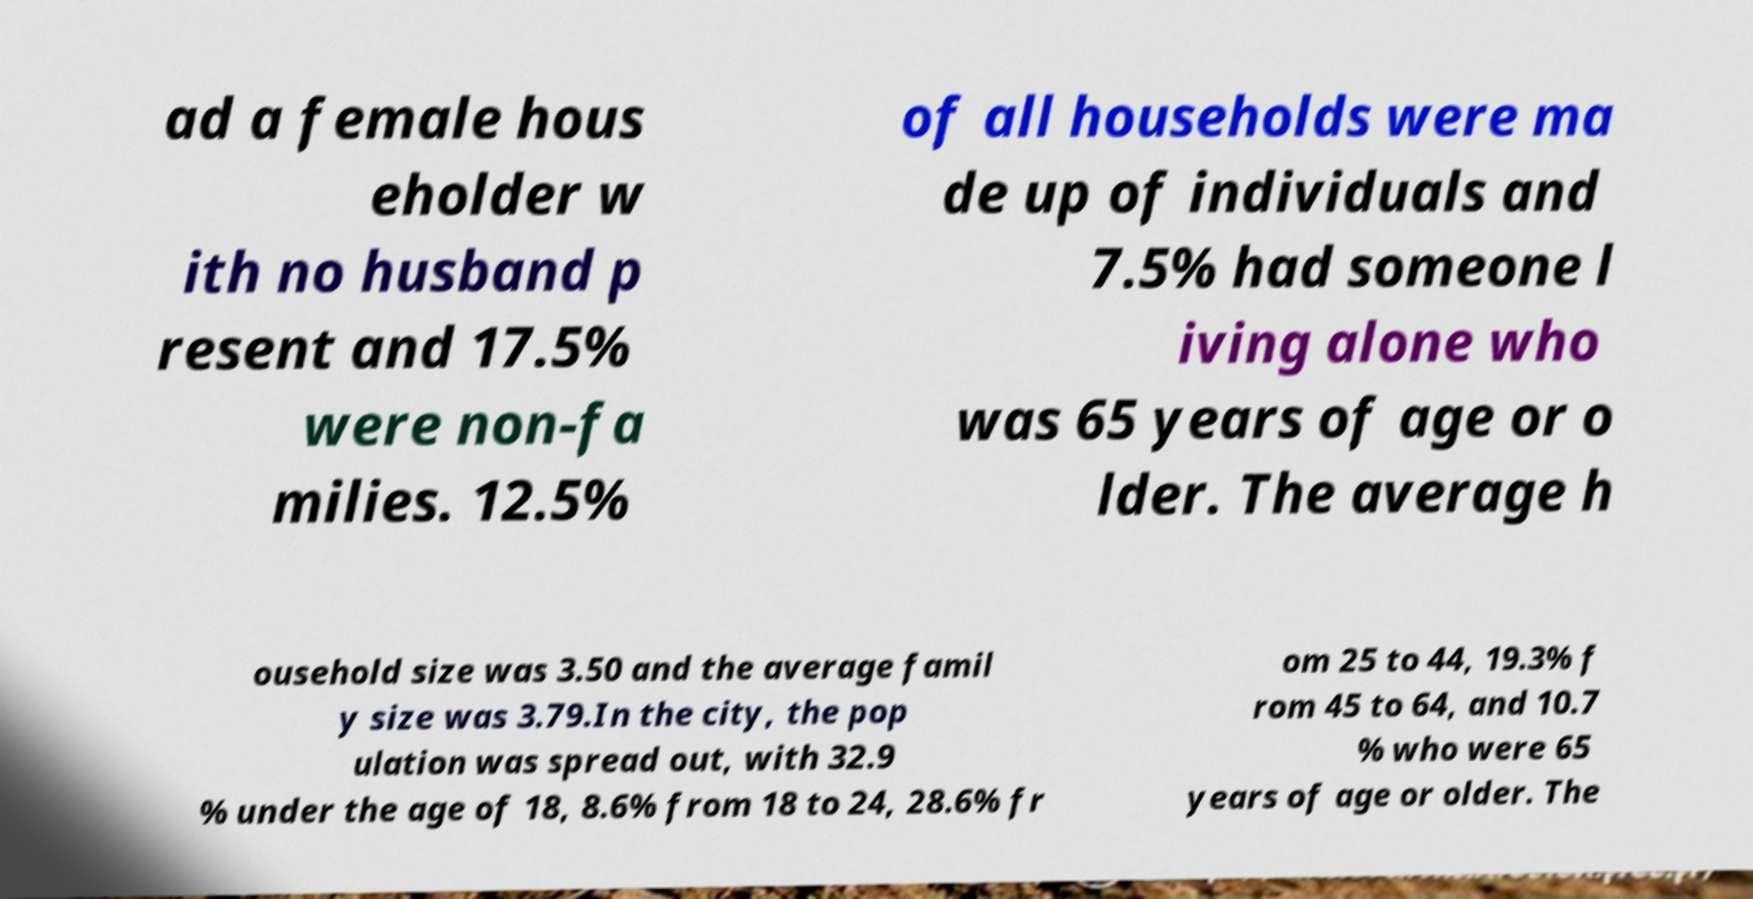Could you extract and type out the text from this image? ad a female hous eholder w ith no husband p resent and 17.5% were non-fa milies. 12.5% of all households were ma de up of individuals and 7.5% had someone l iving alone who was 65 years of age or o lder. The average h ousehold size was 3.50 and the average famil y size was 3.79.In the city, the pop ulation was spread out, with 32.9 % under the age of 18, 8.6% from 18 to 24, 28.6% fr om 25 to 44, 19.3% f rom 45 to 64, and 10.7 % who were 65 years of age or older. The 